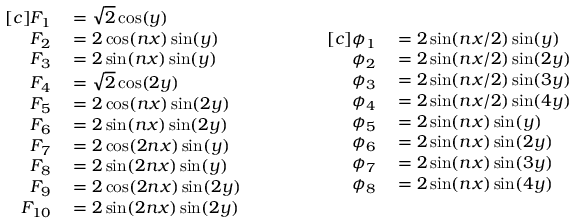<formula> <loc_0><loc_0><loc_500><loc_500>\begin{array} { r l } { [ c ] F _ { 1 } } & = \sqrt { 2 } \cos ( y ) } \\ { F _ { 2 } } & = 2 \cos ( n x ) \sin ( y ) } \\ { F _ { 3 } } & = 2 \sin ( n x ) \sin ( y ) } \\ { F _ { 4 } } & = \sqrt { 2 } \cos ( 2 y ) } \\ { F _ { 5 } } & = 2 \cos ( n x ) \sin ( 2 y ) } \\ { F _ { 6 } } & = 2 \sin ( n x ) \sin ( 2 y ) } \\ { F _ { 7 } } & = 2 \cos ( 2 n x ) \sin ( y ) } \\ { F _ { 8 } } & = 2 \sin ( 2 n x ) \sin ( y ) } \\ { F _ { 9 } } & = 2 \cos ( 2 n x ) \sin ( 2 y ) } \\ { F _ { 1 0 } } & = 2 \sin ( 2 n x ) \sin ( 2 y ) } \end{array} \quad \begin{array} { r l } { [ c ] \phi _ { 1 } } & = 2 \sin ( n x / 2 ) \sin ( y ) } \\ { \phi _ { 2 } } & = 2 \sin ( n x / 2 ) \sin ( 2 y ) } \\ { \phi _ { 3 } } & = 2 \sin ( n x / 2 ) \sin ( 3 y ) } \\ { \phi _ { 4 } } & = 2 \sin ( n x / 2 ) \sin ( 4 y ) } \\ { \phi _ { 5 } } & = 2 \sin ( n x ) \sin ( y ) } \\ { \phi _ { 6 } } & = 2 \sin ( n x ) \sin ( 2 y ) } \\ { \phi _ { 7 } } & = 2 \sin ( n x ) \sin ( 3 y ) } \\ { \phi _ { 8 } } & = 2 \sin ( n x ) \sin ( 4 y ) } \end{array}</formula> 